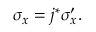Convert formula to latex. <formula><loc_0><loc_0><loc_500><loc_500>\sigma _ { x } = j ^ { * } \sigma _ { x } ^ { \prime } .</formula> 